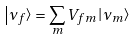Convert formula to latex. <formula><loc_0><loc_0><loc_500><loc_500>\left | \nu _ { f } \right > = \sum _ { m } V _ { f m } \left | \nu _ { m } \right ></formula> 